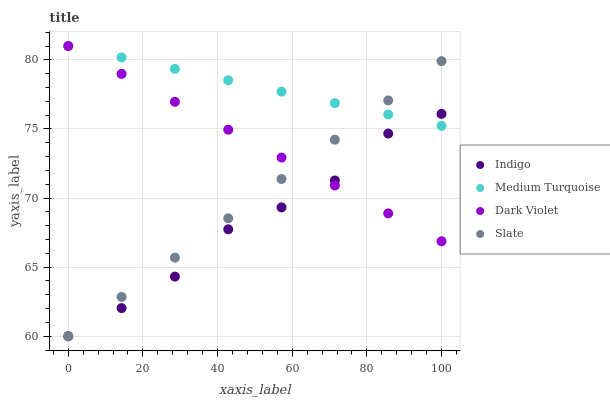Does Indigo have the minimum area under the curve?
Answer yes or no. Yes. Does Medium Turquoise have the maximum area under the curve?
Answer yes or no. Yes. Does Dark Violet have the minimum area under the curve?
Answer yes or no. No. Does Dark Violet have the maximum area under the curve?
Answer yes or no. No. Is Slate the smoothest?
Answer yes or no. Yes. Is Indigo the roughest?
Answer yes or no. Yes. Is Dark Violet the smoothest?
Answer yes or no. No. Is Dark Violet the roughest?
Answer yes or no. No. Does Slate have the lowest value?
Answer yes or no. Yes. Does Dark Violet have the lowest value?
Answer yes or no. No. Does Medium Turquoise have the highest value?
Answer yes or no. Yes. Does Indigo have the highest value?
Answer yes or no. No. Does Medium Turquoise intersect Indigo?
Answer yes or no. Yes. Is Medium Turquoise less than Indigo?
Answer yes or no. No. Is Medium Turquoise greater than Indigo?
Answer yes or no. No. 